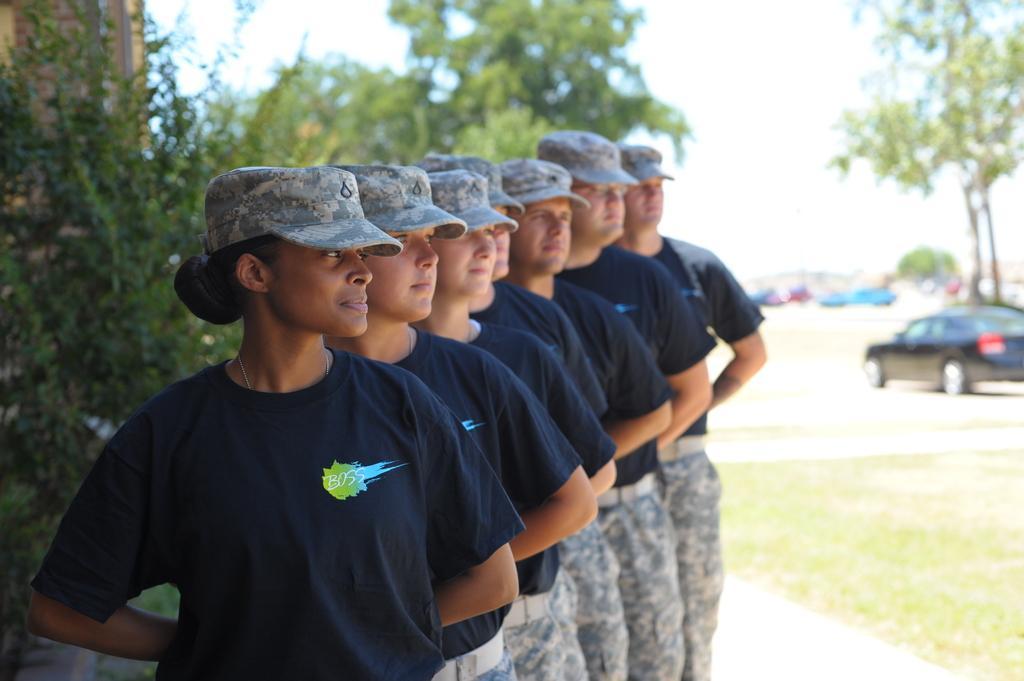Describe this image in one or two sentences. In this image I can see few people are wearing blue t-shirts, caps on their heads and looking at the right side. At the back of these people I can see the trees. In the background there are some cars. 